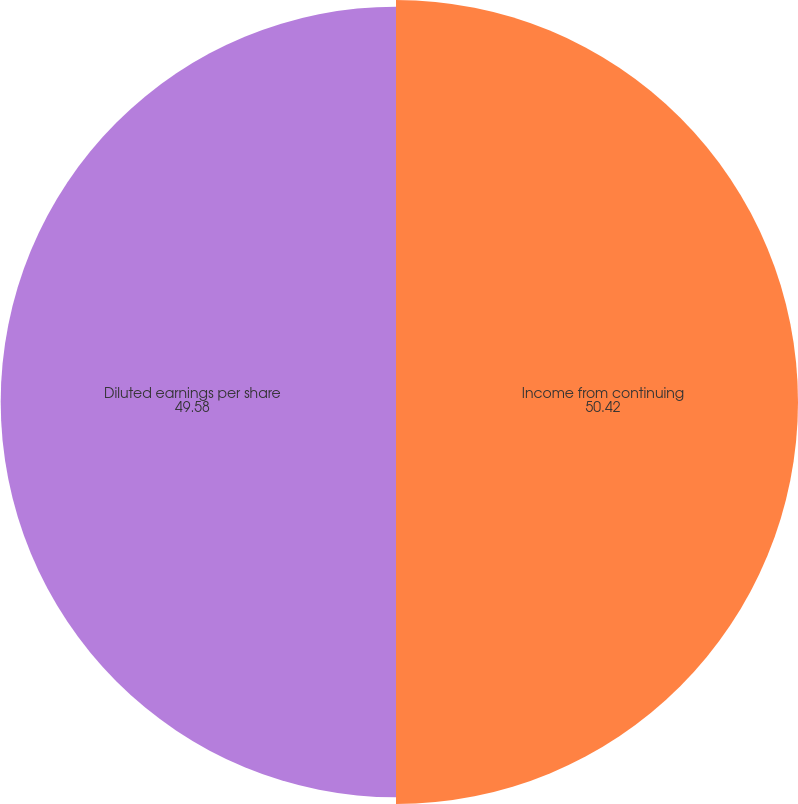Convert chart to OTSL. <chart><loc_0><loc_0><loc_500><loc_500><pie_chart><fcel>Income from continuing<fcel>Diluted earnings per share<nl><fcel>50.42%<fcel>49.58%<nl></chart> 